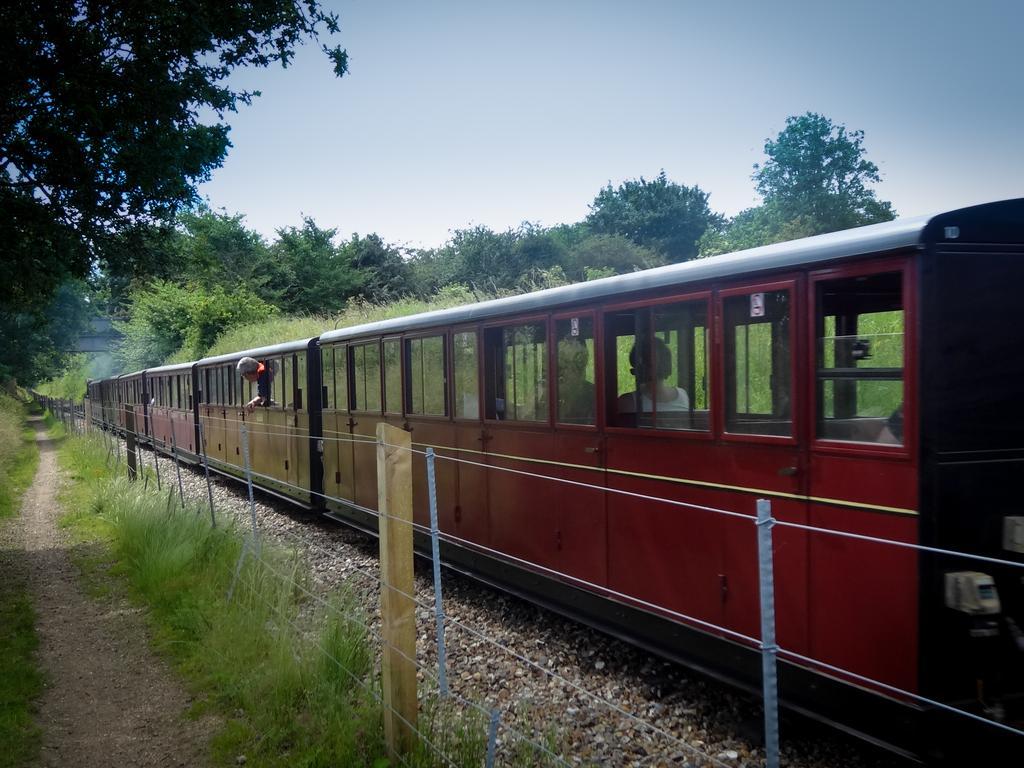Please provide a concise description of this image. In the center of the image there is a train. There is a fencing. In the background of the image there are trees. At the bottom of the image there is grass. 